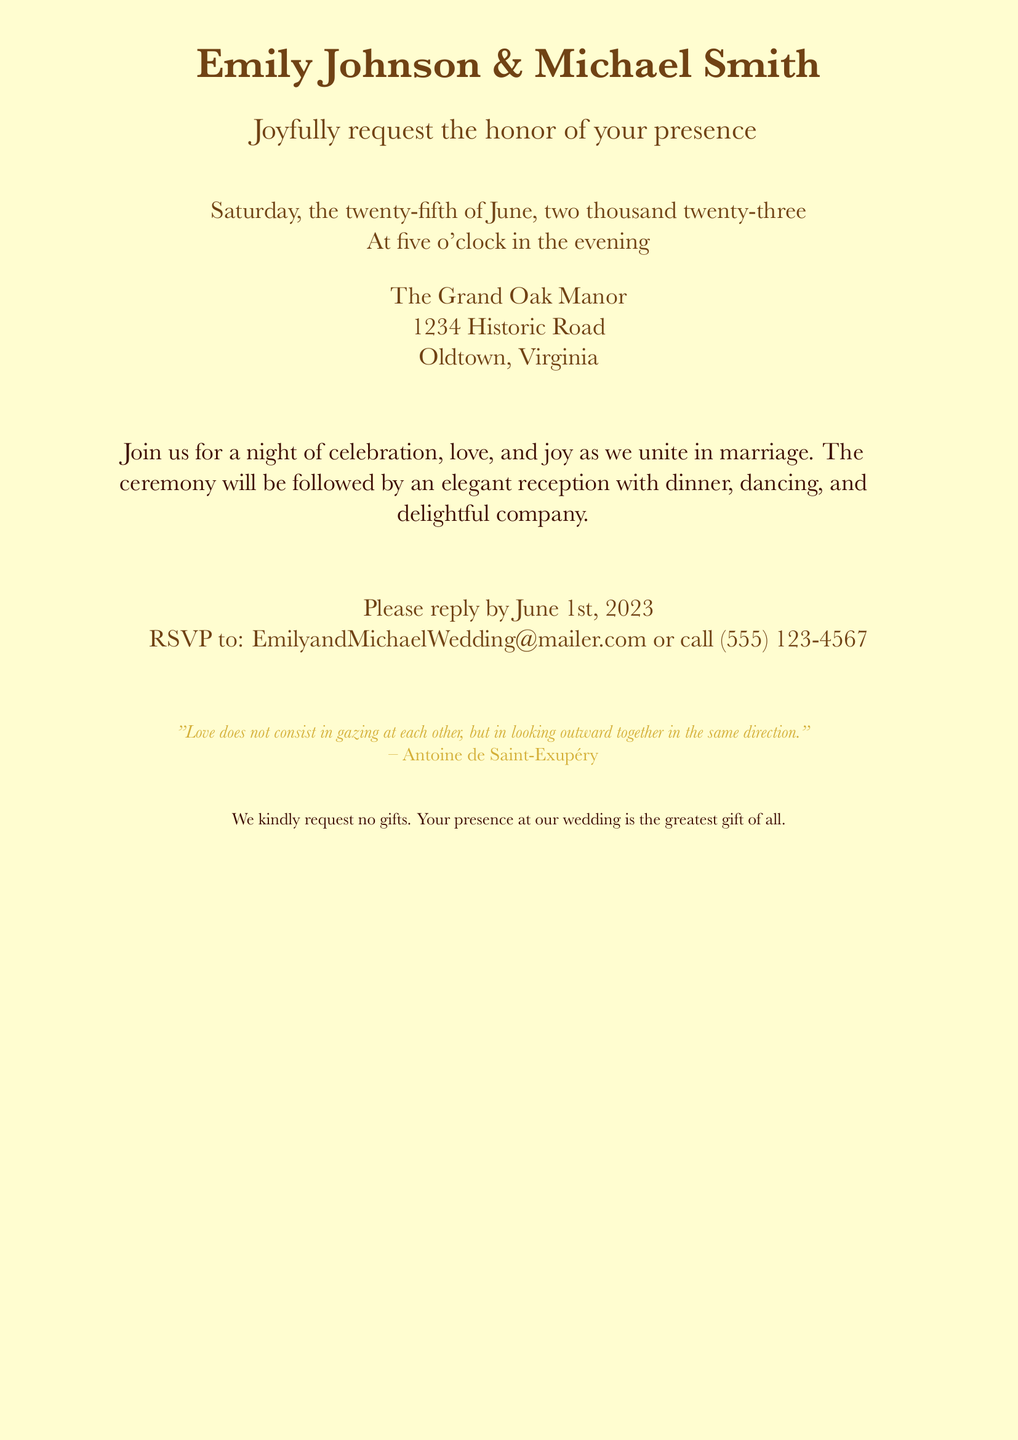What are the names of the couple? The names of the couple are mentioned at the top of the invitation.
Answer: Emily Johnson & Michael Smith What is the date of the wedding? The date is specified in the document as the day of the event.
Answer: Saturday, the twenty-fifth of June, two thousand twenty-three What time does the ceremony start? The start time is indicated clearly in the text.
Answer: Five o'clock in the evening Where is the venue located? The venue is provided in the address section of the invitation.
Answer: The Grand Oak Manor, 1234 Historic Road, Oldtown, Virginia What is the RSVP deadline? The deadline for the RSVP is mentioned in the invitation.
Answer: June 1st, 2023 What are the couple's contact details for RSVP? The contact details for RSVP are included for guests to respond.
Answer: EmilyandMichaelWedding@mailer.com or call (555) 123-4567 What is requested instead of gifts? The couple specifies their preference regarding gifts in the invitation.
Answer: No gifts What is the theme or style of the invitation? The style is implied through the design aspects mentioned in the document.
Answer: Vintage-inspired Who is quoted on the invitation? The invitation includes a quote attributed to a notable author.
Answer: Antoine de Saint-Exupéry 